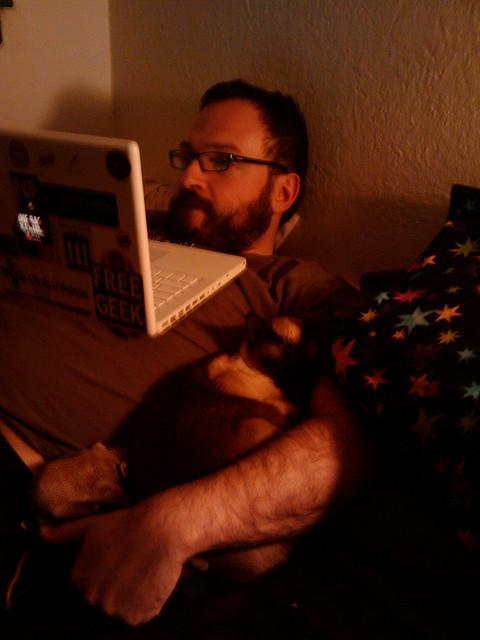How many of the papers in this photo look like bills?
Give a very brief answer. 0. 